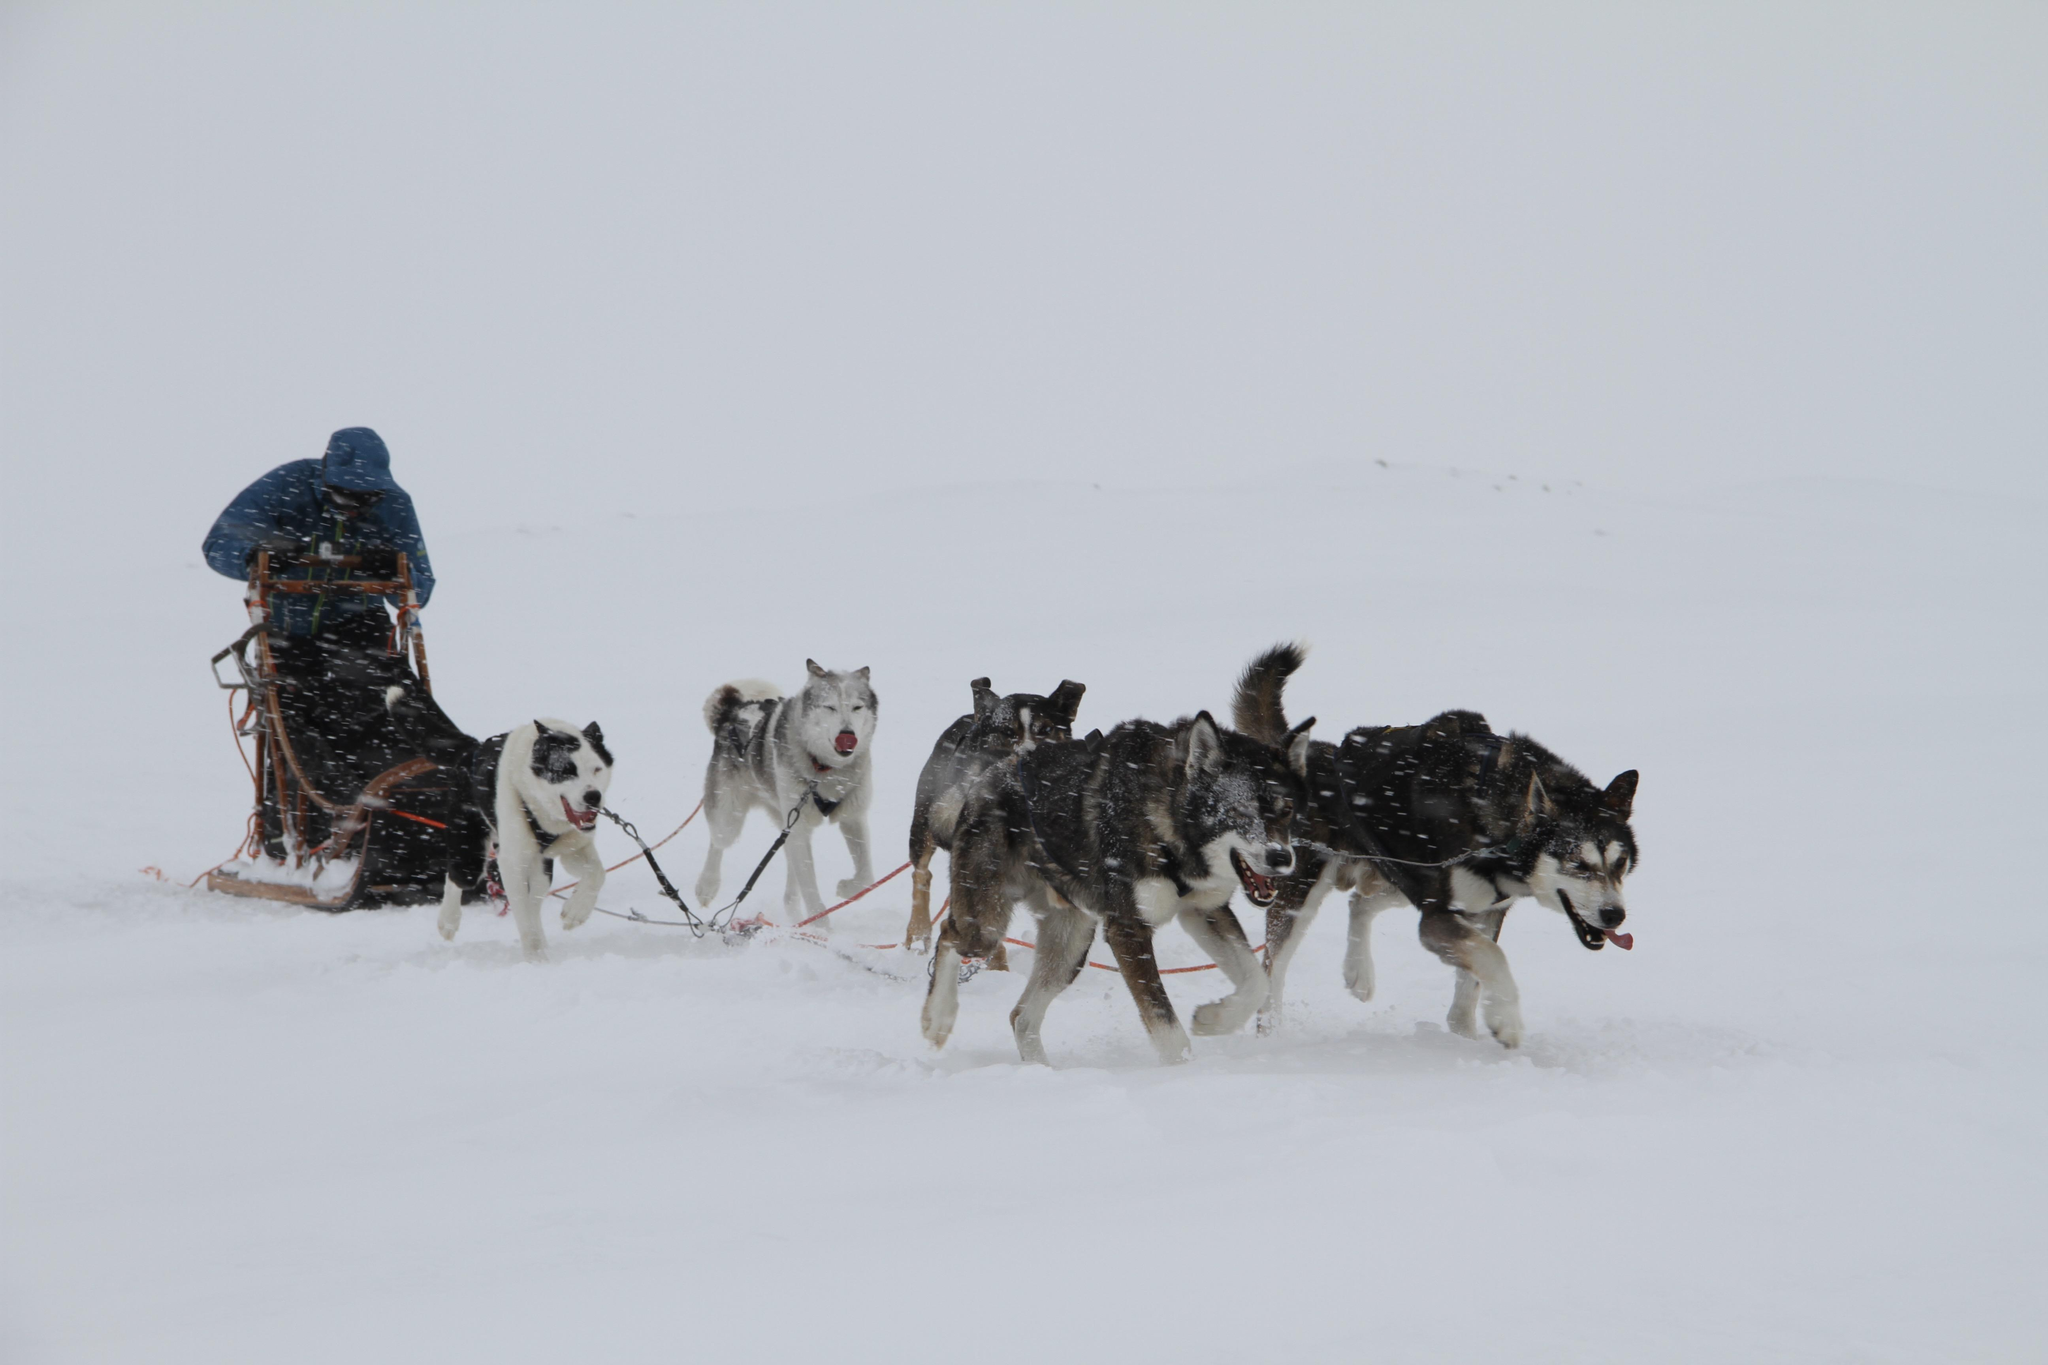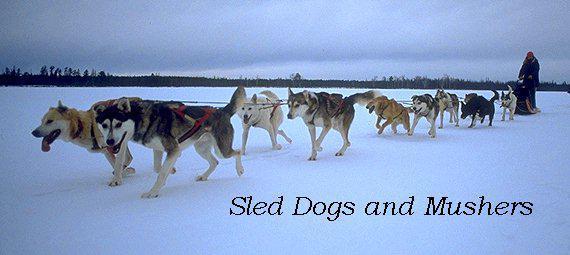The first image is the image on the left, the second image is the image on the right. For the images displayed, is the sentence "The dogs in the left image are heading to the right." factually correct? Answer yes or no. Yes. The first image is the image on the left, the second image is the image on the right. Analyze the images presented: Is the assertion "The dog sled teams in the left and right images move forward at some angle and appear to be heading toward each other." valid? Answer yes or no. Yes. 